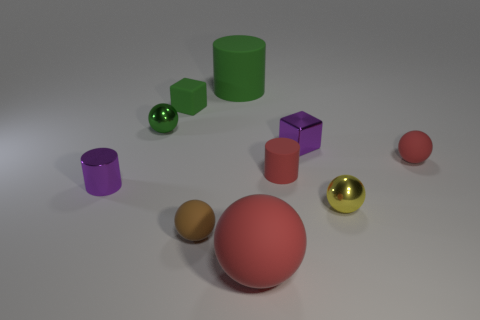Are there any cylinders that have the same color as the large ball?
Ensure brevity in your answer.  Yes. What number of tiny cylinders have the same color as the shiny cube?
Keep it short and to the point. 1. There is a big cylinder; does it have the same color as the metallic sphere that is left of the matte block?
Offer a terse response. Yes. There is a matte sphere in front of the brown thing; are there any objects right of it?
Offer a very short reply. Yes. There is a large green object that is made of the same material as the green block; what shape is it?
Provide a short and direct response. Cylinder. Are there any other things that are the same color as the tiny metal block?
Give a very brief answer. Yes. What material is the cylinder that is to the left of the shiny ball that is behind the tiny purple cube made of?
Your answer should be very brief. Metal. Are there any tiny rubber objects that have the same shape as the big red matte object?
Ensure brevity in your answer.  Yes. How many other things are there of the same shape as the big green object?
Give a very brief answer. 2. What shape is the object that is to the right of the purple block and behind the small yellow metallic object?
Your response must be concise. Sphere. 